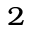Convert formula to latex. <formula><loc_0><loc_0><loc_500><loc_500>^ { 2 }</formula> 